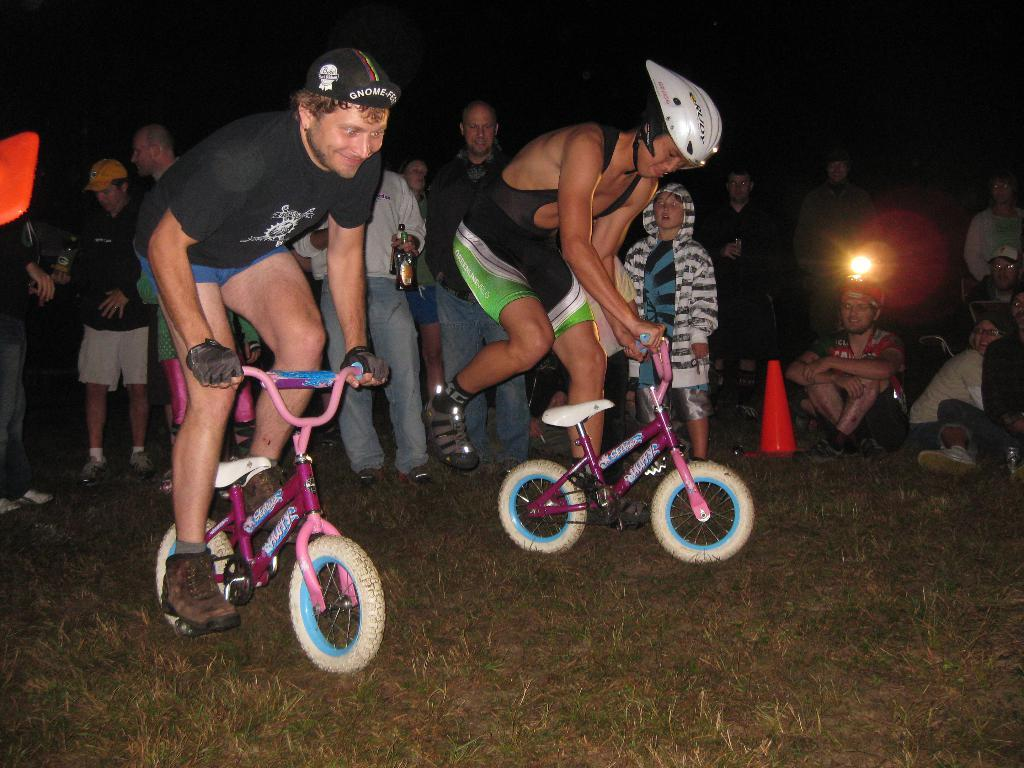What activity are the two persons in the image engaged in? The two persons in the image are riding a cycle together. What can be seen in the background of the image? There are people standing in the background of the image. What are the people in the background doing? The people in the background are watching the cyclists. What type of coach can be seen in the image? There is no coach present in the image; it features two persons riding a cycle and people standing in the background. 